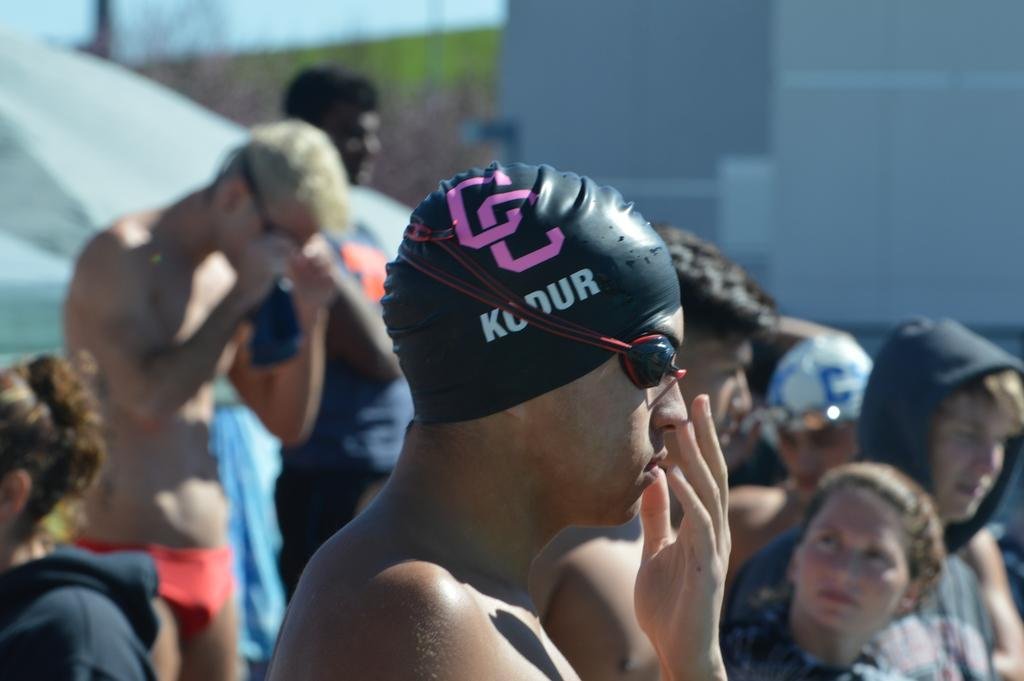What is the appearance of the man in the foreground of the image? The man in the foreground of the image has a headband and spectacles. What can be seen in the background of the image? There are persons, trees, grass, a tent, and the sky visible in the background of the image. How many elements are present in the background of the image? There are five elements present in the background: persons, trees, grass, a tent, and the sky. What type of wood is the giant holding in the image? There are no giants or wood present in the image. What songs are the persons in the background singing in the image? There is no indication in the image that the persons in the background are singing any songs. 